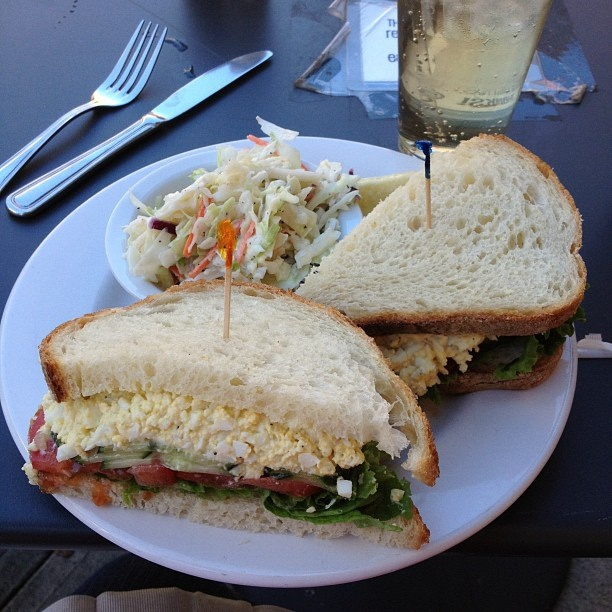Describe the objects in this image and their specific colors. I can see dining table in darkgray, black, gray, lightblue, and tan tones, sandwich in gray, darkgray, tan, and lightgray tones, sandwich in gray, darkgray, black, lightgray, and maroon tones, bowl in gray, darkgray, lightblue, and lightgray tones, and cup in gray, darkgray, and black tones in this image. 